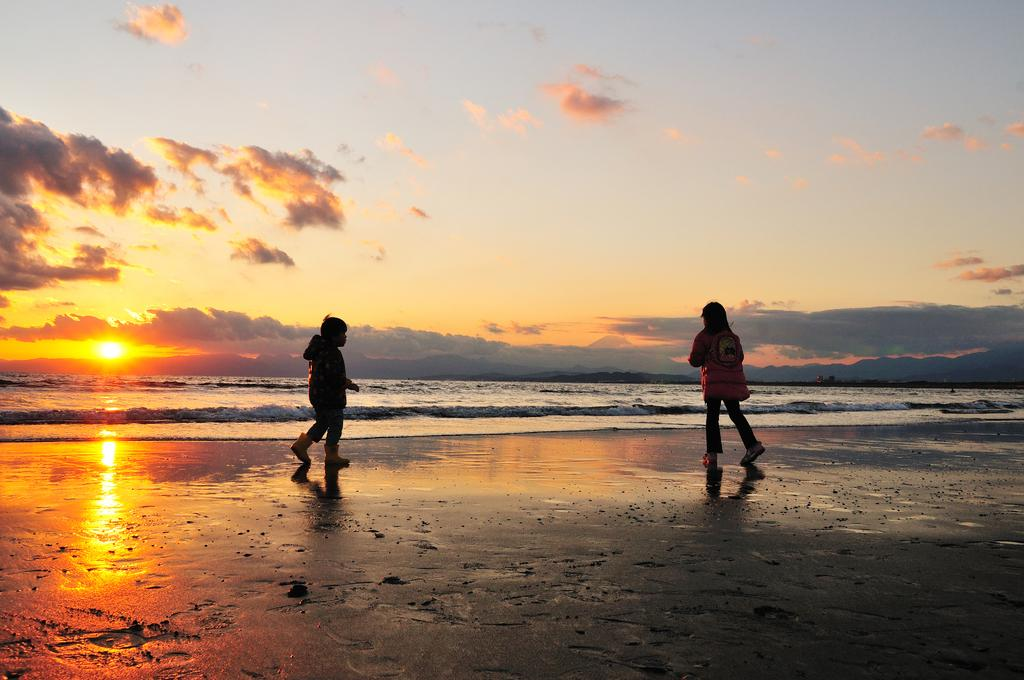How many children are present in the image? There are two children standing in the image. What is visible in the background of the image? Water is visible in the image. What is the condition of the sky in the image? The sun is visible in the sky. What type of paste can be seen on the children's hands in the image? There is no paste visible on the children's hands in the image. Can you tell me how many frogs are hopping near the water in the image? There are no frogs present in the image; only the two children and water are visible. 